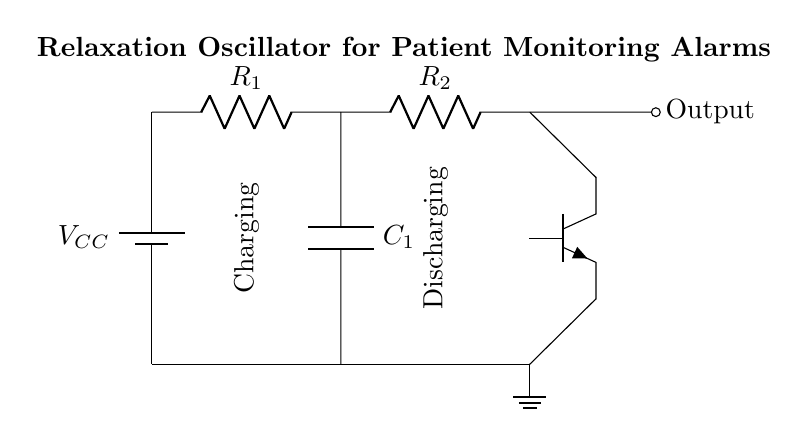What type of transistor is used in the circuit? The circuit diagram shows an NPN transistor indicated by the symbol used. This is a standard representation for an NPN transistor in circuit designs.
Answer: NPN What are the values of the resistors used in this relaxation oscillator? The circuit diagram includes two resistors labeled as R1 and R2. However, specific numerical values are not provided in the diagram itself; they would typically be determined from design specifications.
Answer: Not specified What is the purpose of capacitor C1 in the circuit? The capacitor C1 is used for charging and discharging, which is essential for generating oscillations. In relation to the relaxation oscillator, it helps to create the timing intervals necessary for the alarm signals.
Answer: Timing How does the output of the circuit behave during the charging phase? During the charging phase, the output will rise as the capacitor C1 charges through the resistors. This change in output is integral for the operation of the patient monitoring alarm.
Answer: Rises What determines the frequency of oscillation in this circuit? The frequency of oscillation is determined by the values of resistors R1, R2, and the capacitor C1. The time constant created by these components defines how quickly the capacitor charges and discharges, resulting in the oscillation frequency.
Answer: Resistor and capacitor values What is the primary application of this relaxation oscillator? The primary application of this relaxation oscillator circuit is in patient monitoring alarms, where it is used to create alarm signals based on physiological parameters monitored in healthcare facilities.
Answer: Patient monitoring alarms 